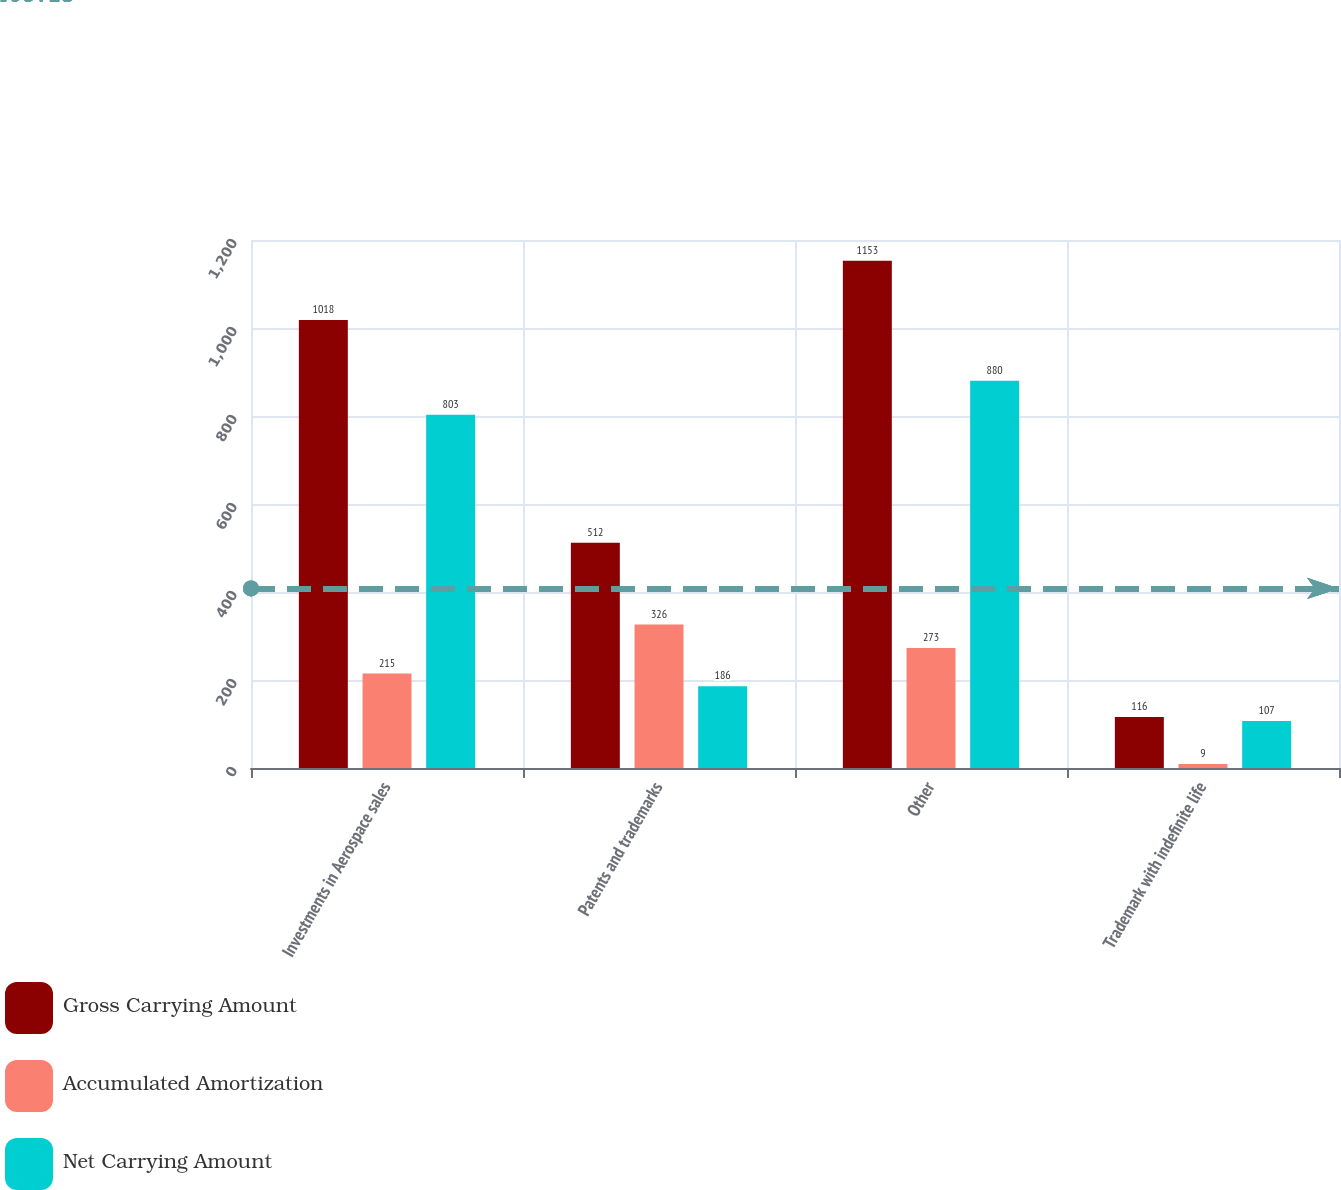Convert chart. <chart><loc_0><loc_0><loc_500><loc_500><stacked_bar_chart><ecel><fcel>Investments in Aerospace sales<fcel>Patents and trademarks<fcel>Other<fcel>Trademark with indefinite life<nl><fcel>Gross Carrying Amount<fcel>1018<fcel>512<fcel>1153<fcel>116<nl><fcel>Accumulated Amortization<fcel>215<fcel>326<fcel>273<fcel>9<nl><fcel>Net Carrying Amount<fcel>803<fcel>186<fcel>880<fcel>107<nl></chart> 